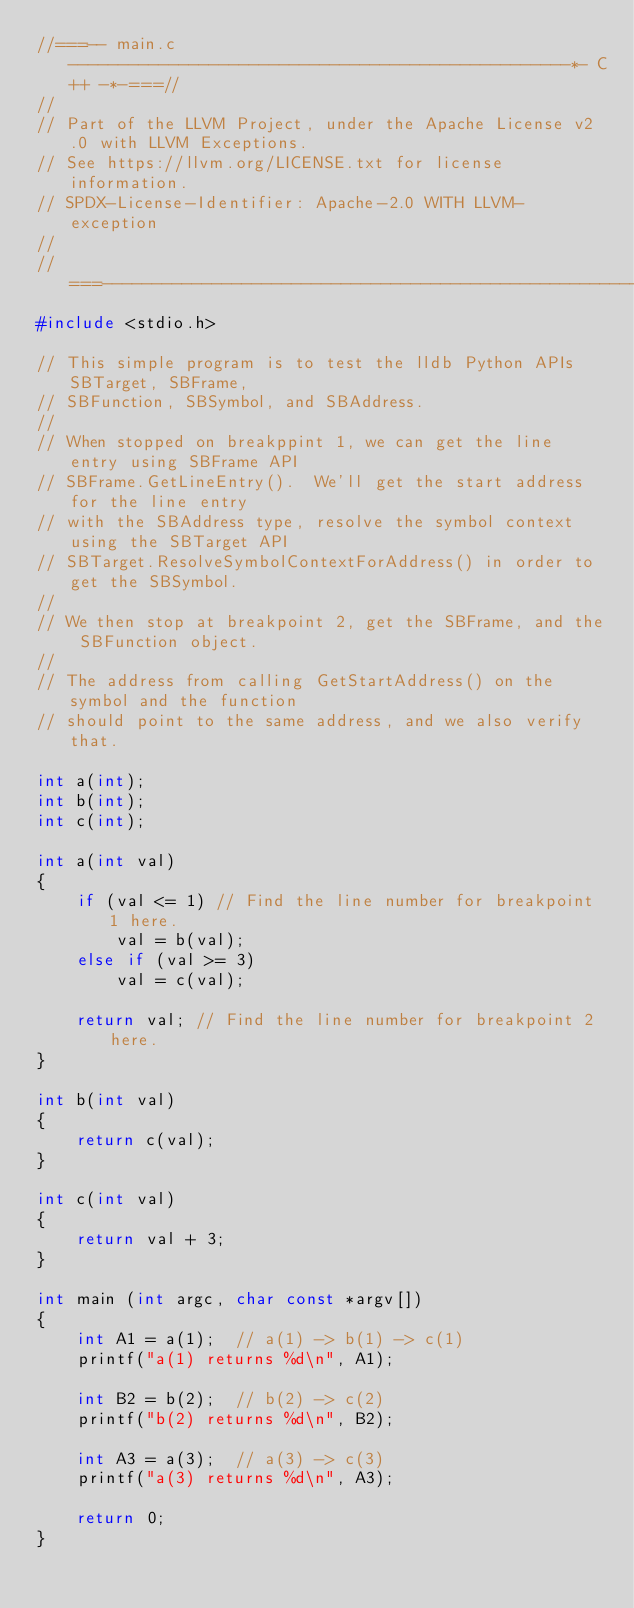Convert code to text. <code><loc_0><loc_0><loc_500><loc_500><_C_>//===-- main.c --------------------------------------------------*- C++ -*-===//
//
// Part of the LLVM Project, under the Apache License v2.0 with LLVM Exceptions.
// See https://llvm.org/LICENSE.txt for license information.
// SPDX-License-Identifier: Apache-2.0 WITH LLVM-exception
//
//===----------------------------------------------------------------------===//
#include <stdio.h>

// This simple program is to test the lldb Python APIs SBTarget, SBFrame,
// SBFunction, SBSymbol, and SBAddress.
//
// When stopped on breakppint 1, we can get the line entry using SBFrame API
// SBFrame.GetLineEntry().  We'll get the start address for the line entry
// with the SBAddress type, resolve the symbol context using the SBTarget API
// SBTarget.ResolveSymbolContextForAddress() in order to get the SBSymbol.
//
// We then stop at breakpoint 2, get the SBFrame, and the SBFunction object.
//
// The address from calling GetStartAddress() on the symbol and the function
// should point to the same address, and we also verify that.

int a(int);
int b(int);
int c(int);

int a(int val)
{
    if (val <= 1) // Find the line number for breakpoint 1 here.
        val = b(val);
    else if (val >= 3)
        val = c(val);

    return val; // Find the line number for breakpoint 2 here.
}

int b(int val)
{
    return c(val);
}

int c(int val)
{
    return val + 3;
}

int main (int argc, char const *argv[])
{
    int A1 = a(1);  // a(1) -> b(1) -> c(1)
    printf("a(1) returns %d\n", A1);
    
    int B2 = b(2);  // b(2) -> c(2)
    printf("b(2) returns %d\n", B2);
    
    int A3 = a(3);  // a(3) -> c(3)
    printf("a(3) returns %d\n", A3);
    
    return 0;
}
</code> 